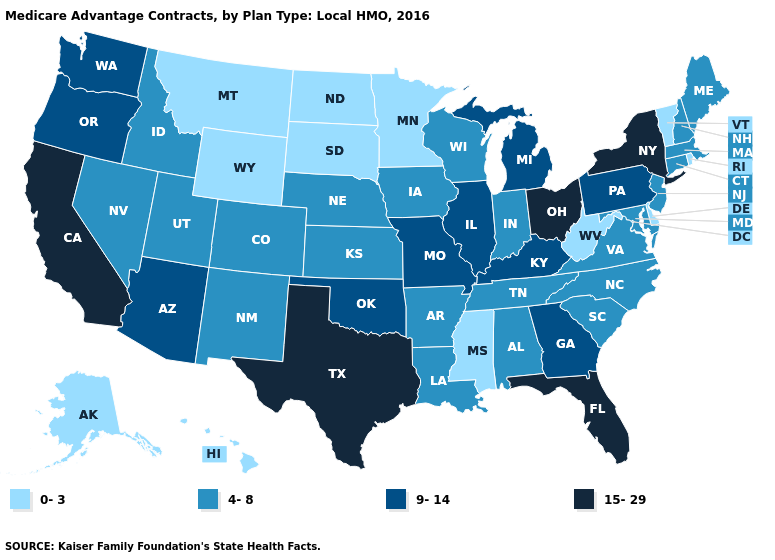Name the states that have a value in the range 0-3?
Write a very short answer. Alaska, Delaware, Hawaii, Minnesota, Mississippi, Montana, North Dakota, Rhode Island, South Dakota, Vermont, West Virginia, Wyoming. What is the highest value in the Northeast ?
Keep it brief. 15-29. Among the states that border Rhode Island , which have the lowest value?
Give a very brief answer. Connecticut, Massachusetts. What is the highest value in the USA?
Answer briefly. 15-29. Name the states that have a value in the range 4-8?
Quick response, please. Alabama, Arkansas, Colorado, Connecticut, Iowa, Idaho, Indiana, Kansas, Louisiana, Massachusetts, Maryland, Maine, North Carolina, Nebraska, New Hampshire, New Jersey, New Mexico, Nevada, South Carolina, Tennessee, Utah, Virginia, Wisconsin. What is the lowest value in the USA?
Answer briefly. 0-3. Does California have the same value as Texas?
Short answer required. Yes. Does Maine have a lower value than Oregon?
Keep it brief. Yes. Name the states that have a value in the range 15-29?
Short answer required. California, Florida, New York, Ohio, Texas. Does Ohio have the same value as California?
Keep it brief. Yes. What is the value of West Virginia?
Be succinct. 0-3. What is the highest value in states that border Missouri?
Quick response, please. 9-14. Name the states that have a value in the range 4-8?
Give a very brief answer. Alabama, Arkansas, Colorado, Connecticut, Iowa, Idaho, Indiana, Kansas, Louisiana, Massachusetts, Maryland, Maine, North Carolina, Nebraska, New Hampshire, New Jersey, New Mexico, Nevada, South Carolina, Tennessee, Utah, Virginia, Wisconsin. Name the states that have a value in the range 4-8?
Concise answer only. Alabama, Arkansas, Colorado, Connecticut, Iowa, Idaho, Indiana, Kansas, Louisiana, Massachusetts, Maryland, Maine, North Carolina, Nebraska, New Hampshire, New Jersey, New Mexico, Nevada, South Carolina, Tennessee, Utah, Virginia, Wisconsin. Does the first symbol in the legend represent the smallest category?
Quick response, please. Yes. 